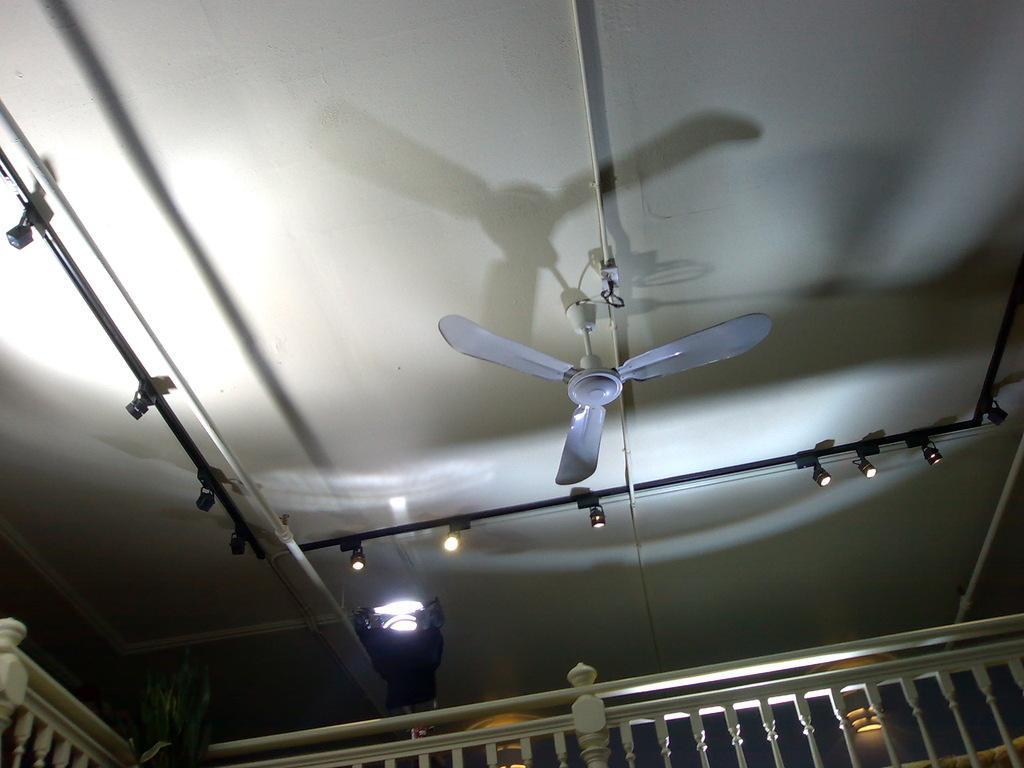Describe this image in one or two sentences. In this picture I can see the railing in front and on the ceiling I can see the rods on which there are lights and I can see a fan. I can also see few more lights on the bottom of this picture. 